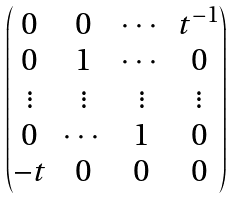<formula> <loc_0><loc_0><loc_500><loc_500>\begin{pmatrix} 0 & 0 & \cdots & t ^ { - 1 } \\ 0 & 1 & \cdots & 0 \\ \vdots & \vdots & \vdots & \vdots \\ 0 & \cdots & 1 & 0 \\ - t & 0 & 0 & 0 \end{pmatrix}</formula> 